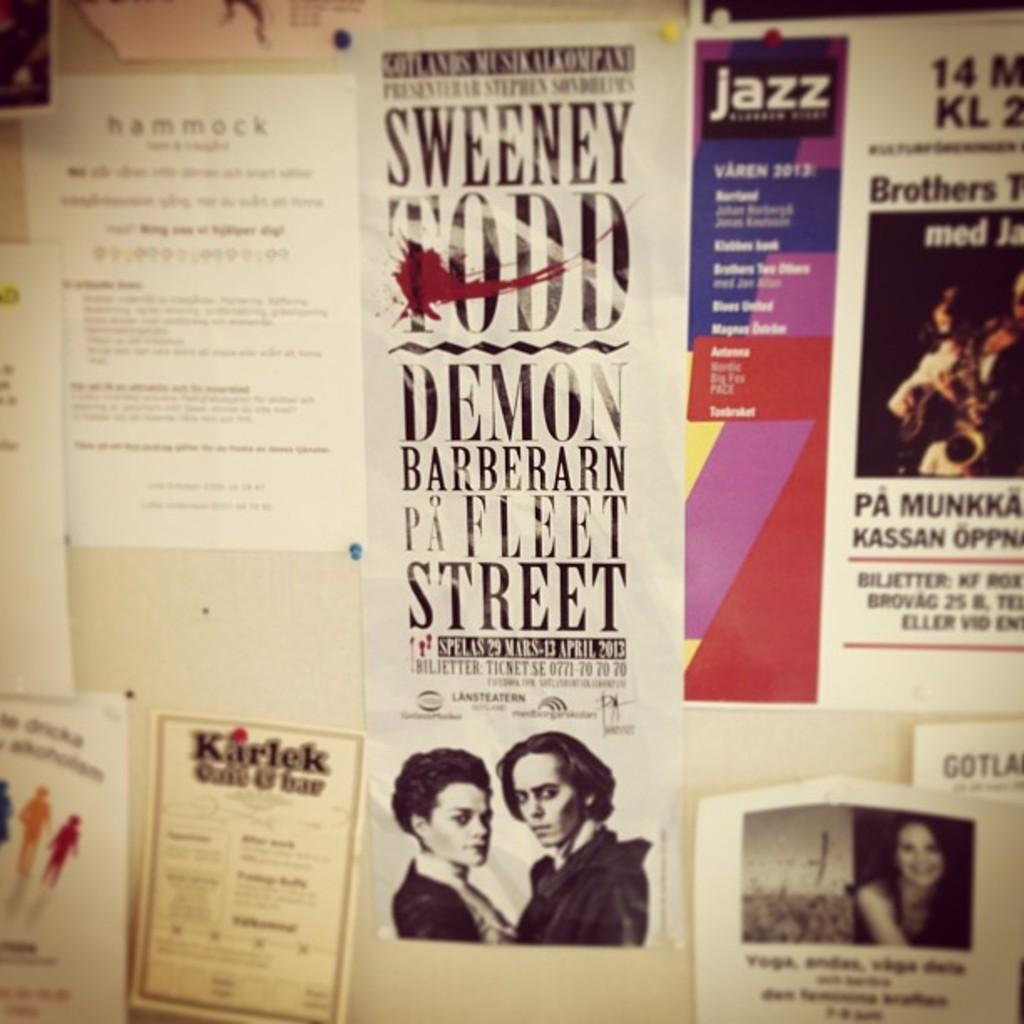What type of objects can be seen in the image? There are papers and pictures in the image. What is on the papers? There is writing on the papers. What type of game is being played in the image? There is no game being played in the image; it only contains papers and pictures with writing on them. 